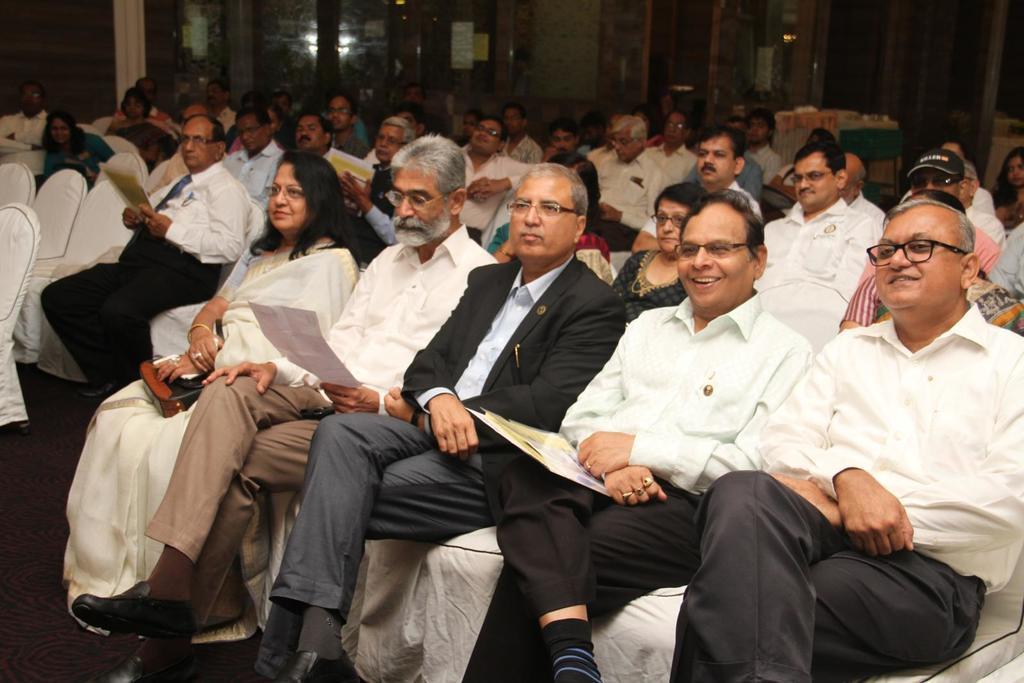Describe this image in one or two sentences. In this image we can able to see few persons are sitting on chairs in a room, and some of them are holding papers. 